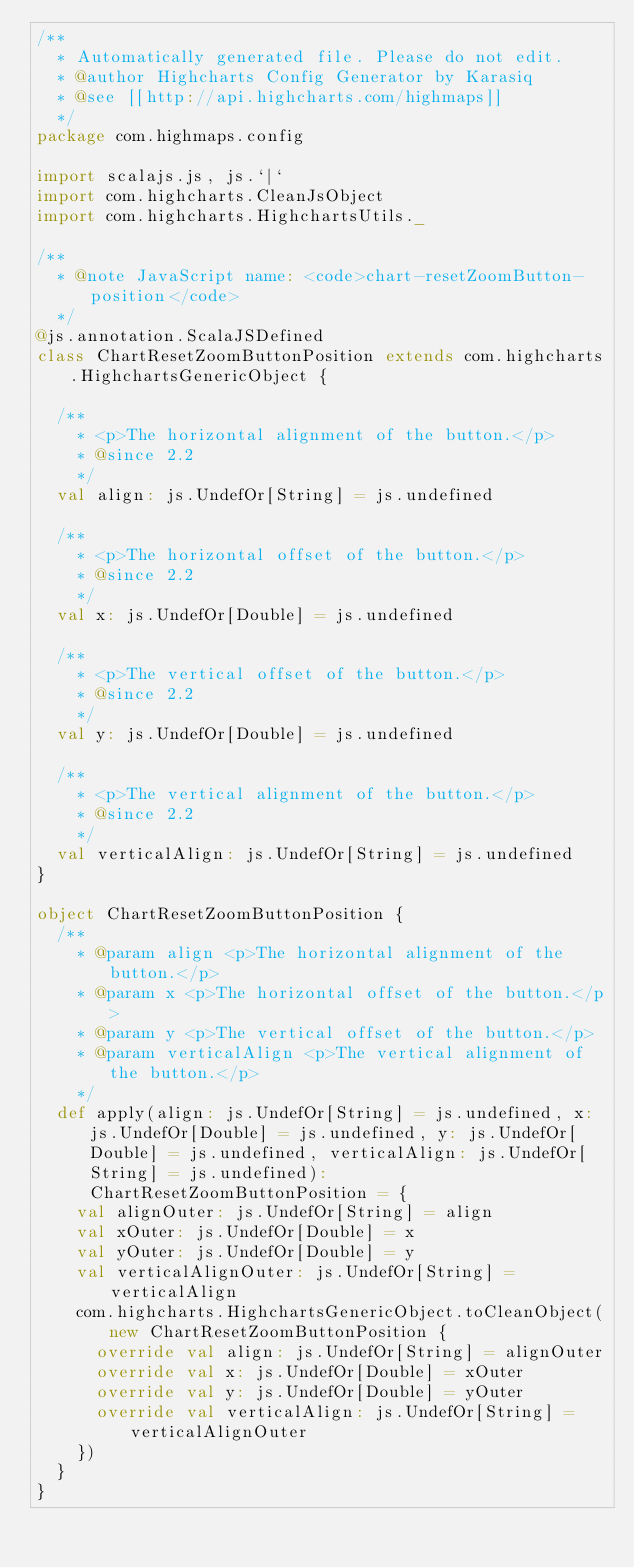Convert code to text. <code><loc_0><loc_0><loc_500><loc_500><_Scala_>/**
  * Automatically generated file. Please do not edit.
  * @author Highcharts Config Generator by Karasiq
  * @see [[http://api.highcharts.com/highmaps]]
  */
package com.highmaps.config

import scalajs.js, js.`|`
import com.highcharts.CleanJsObject
import com.highcharts.HighchartsUtils._

/**
  * @note JavaScript name: <code>chart-resetZoomButton-position</code>
  */
@js.annotation.ScalaJSDefined
class ChartResetZoomButtonPosition extends com.highcharts.HighchartsGenericObject {

  /**
    * <p>The horizontal alignment of the button.</p>
    * @since 2.2
    */
  val align: js.UndefOr[String] = js.undefined

  /**
    * <p>The horizontal offset of the button.</p>
    * @since 2.2
    */
  val x: js.UndefOr[Double] = js.undefined

  /**
    * <p>The vertical offset of the button.</p>
    * @since 2.2
    */
  val y: js.UndefOr[Double] = js.undefined

  /**
    * <p>The vertical alignment of the button.</p>
    * @since 2.2
    */
  val verticalAlign: js.UndefOr[String] = js.undefined
}

object ChartResetZoomButtonPosition {
  /**
    * @param align <p>The horizontal alignment of the button.</p>
    * @param x <p>The horizontal offset of the button.</p>
    * @param y <p>The vertical offset of the button.</p>
    * @param verticalAlign <p>The vertical alignment of the button.</p>
    */
  def apply(align: js.UndefOr[String] = js.undefined, x: js.UndefOr[Double] = js.undefined, y: js.UndefOr[Double] = js.undefined, verticalAlign: js.UndefOr[String] = js.undefined): ChartResetZoomButtonPosition = {
    val alignOuter: js.UndefOr[String] = align
    val xOuter: js.UndefOr[Double] = x
    val yOuter: js.UndefOr[Double] = y
    val verticalAlignOuter: js.UndefOr[String] = verticalAlign
    com.highcharts.HighchartsGenericObject.toCleanObject(new ChartResetZoomButtonPosition {
      override val align: js.UndefOr[String] = alignOuter
      override val x: js.UndefOr[Double] = xOuter
      override val y: js.UndefOr[Double] = yOuter
      override val verticalAlign: js.UndefOr[String] = verticalAlignOuter
    })
  }
}
</code> 